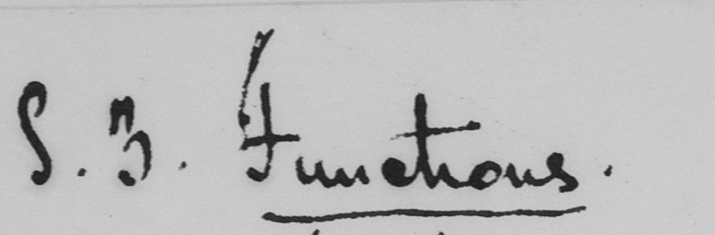What does this handwritten line say? S . 3 . Functions . 